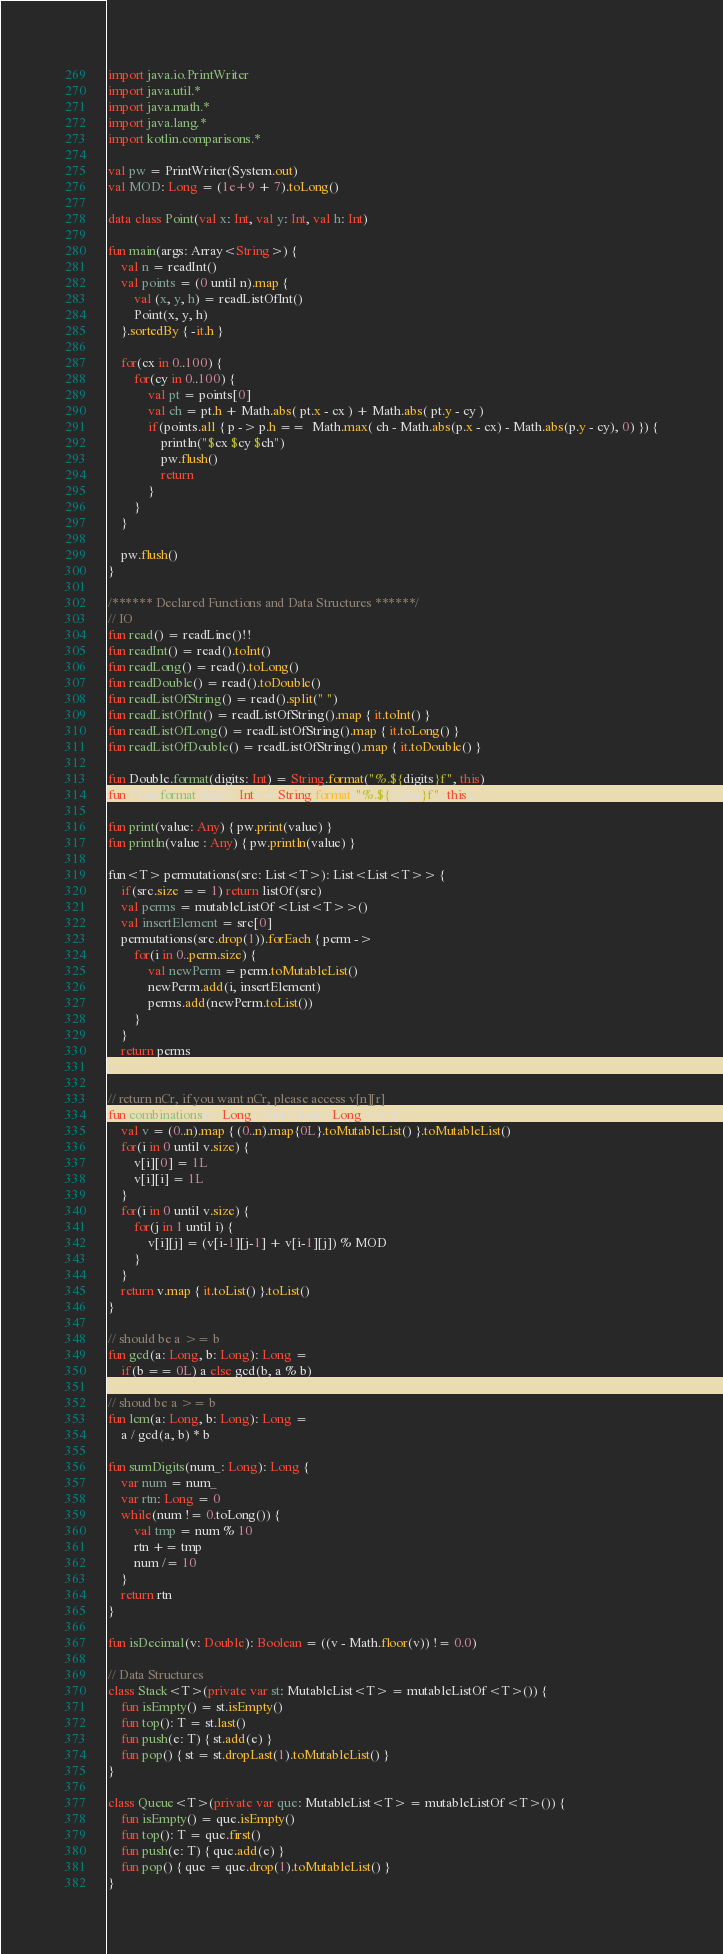<code> <loc_0><loc_0><loc_500><loc_500><_Kotlin_>import java.io.PrintWriter
import java.util.*
import java.math.*
import java.lang.*
import kotlin.comparisons.*

val pw = PrintWriter(System.out)
val MOD: Long = (1e+9 + 7).toLong()

data class Point(val x: Int, val y: Int, val h: Int)

fun main(args: Array<String>) {
    val n = readInt()        
    val points = (0 until n).map {
        val (x, y, h) = readListOfInt()
        Point(x, y, h)
    }.sortedBy { -it.h }

    for(cx in 0..100) {
        for(cy in 0..100) {
            val pt = points[0]
            val ch = pt.h + Math.abs( pt.x - cx ) + Math.abs( pt.y - cy )
            if(points.all { p -> p.h ==  Math.max( ch - Math.abs(p.x - cx) - Math.abs(p.y - cy), 0) }) {
                println("$cx $cy $ch")
                pw.flush()
                return
            }
        }
    }

    pw.flush()
}

/****** Declared Functions and Data Structures ******/
// IO
fun read() = readLine()!!
fun readInt() = read().toInt()
fun readLong() = read().toLong()
fun readDouble() = read().toDouble()
fun readListOfString() = read().split(" ")
fun readListOfInt() = readListOfString().map { it.toInt() }
fun readListOfLong() = readListOfString().map { it.toLong() }
fun readListOfDouble() = readListOfString().map { it.toDouble() }

fun Double.format(digits: Int) = String.format("%.${digits}f", this)
fun Float.format(digits: Int) = String.format("%.${digits}f", this)

fun print(value: Any) { pw.print(value) }
fun println(value : Any) { pw.println(value) }

fun<T> permutations(src: List<T>): List<List<T>> {
    if(src.size == 1) return listOf(src)
    val perms = mutableListOf<List<T>>()
    val insertElement = src[0]
    permutations(src.drop(1)).forEach { perm ->
        for(i in 0..perm.size) {
            val newPerm = perm.toMutableList()
            newPerm.add(i, insertElement)
            perms.add(newPerm.toList())
        }
    }
    return perms
}

// return nCr, if you want nCr, please access v[n][r]
fun combinations(n: Long): List<List<Long>> {
    val v = (0..n).map { (0..n).map{0L}.toMutableList() }.toMutableList()
    for(i in 0 until v.size) {
        v[i][0] = 1L
        v[i][i] = 1L
    }
    for(i in 0 until v.size) {
        for(j in 1 until i) {
            v[i][j] = (v[i-1][j-1] + v[i-1][j]) % MOD
        }
    }
    return v.map { it.toList() }.toList()
}

// should be a >= b
fun gcd(a: Long, b: Long): Long = 
    if(b == 0L) a else gcd(b, a % b)

// shoud be a >= b
fun lcm(a: Long, b: Long): Long = 
    a / gcd(a, b) * b

fun sumDigits(num_: Long): Long {
    var num = num_
    var rtn: Long = 0
    while(num != 0.toLong()) {
        val tmp = num % 10
        rtn += tmp
        num /= 10
    }
    return rtn
}

fun isDecimal(v: Double): Boolean = ((v - Math.floor(v)) != 0.0)

// Data Structures
class Stack<T>(private var st: MutableList<T> = mutableListOf<T>()) {
    fun isEmpty() = st.isEmpty()
    fun top(): T = st.last()
    fun push(e: T) { st.add(e) }
    fun pop() { st = st.dropLast(1).toMutableList() }
}

class Queue<T>(private var que: MutableList<T> = mutableListOf<T>()) {
    fun isEmpty() = que.isEmpty()
    fun top(): T = que.first()
    fun push(e: T) { que.add(e) }
    fun pop() { que = que.drop(1).toMutableList() }
}
</code> 